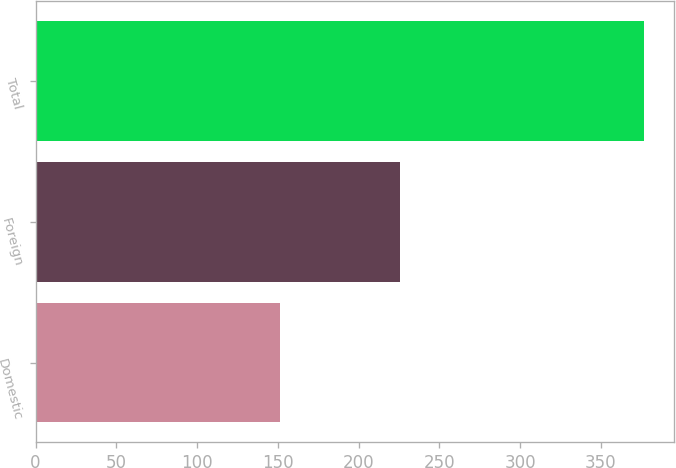Convert chart. <chart><loc_0><loc_0><loc_500><loc_500><bar_chart><fcel>Domestic<fcel>Foreign<fcel>Total<nl><fcel>151.2<fcel>225.4<fcel>376.6<nl></chart> 